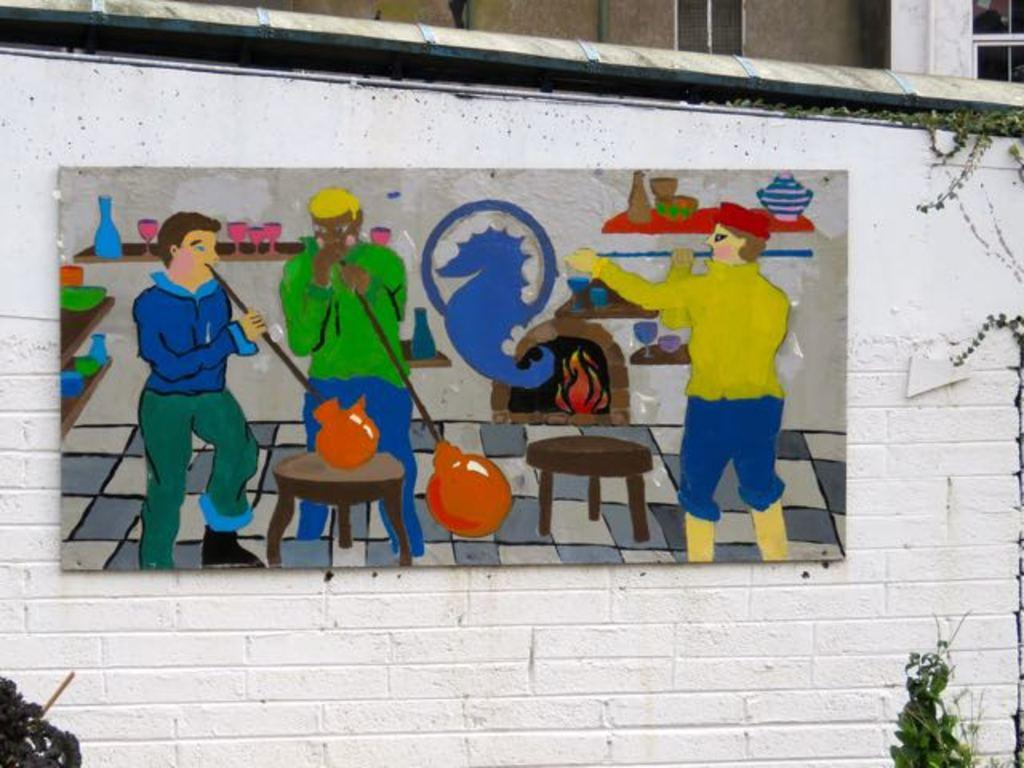What is the color of the wall in the image? The wall in the image is white. What is hanging on the wall? There is a painting on the wall. What else can be seen near the painting? There are plants on either side of the painting. Can you describe the background of the image? There appears to be a building behind the wall. How many crows are sitting on the painting in the image? There are no crows present in the image. What type of glue is being used to attach the painting to the wall? There is no information about glue or any adhesive being used in the image. 